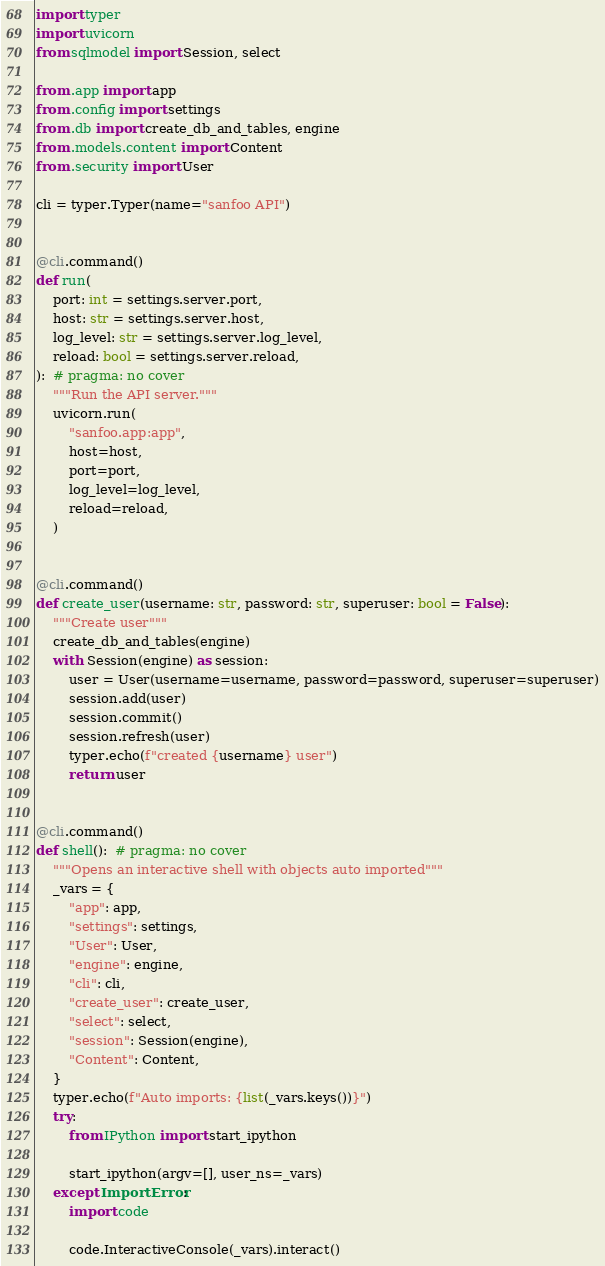<code> <loc_0><loc_0><loc_500><loc_500><_Python_>import typer
import uvicorn
from sqlmodel import Session, select

from .app import app
from .config import settings
from .db import create_db_and_tables, engine
from .models.content import Content
from .security import User

cli = typer.Typer(name="sanfoo API")


@cli.command()
def run(
    port: int = settings.server.port,
    host: str = settings.server.host,
    log_level: str = settings.server.log_level,
    reload: bool = settings.server.reload,
):  # pragma: no cover
    """Run the API server."""
    uvicorn.run(
        "sanfoo.app:app",
        host=host,
        port=port,
        log_level=log_level,
        reload=reload,
    )


@cli.command()
def create_user(username: str, password: str, superuser: bool = False):
    """Create user"""
    create_db_and_tables(engine)
    with Session(engine) as session:
        user = User(username=username, password=password, superuser=superuser)
        session.add(user)
        session.commit()
        session.refresh(user)
        typer.echo(f"created {username} user")
        return user


@cli.command()
def shell():  # pragma: no cover
    """Opens an interactive shell with objects auto imported"""
    _vars = {
        "app": app,
        "settings": settings,
        "User": User,
        "engine": engine,
        "cli": cli,
        "create_user": create_user,
        "select": select,
        "session": Session(engine),
        "Content": Content,
    }
    typer.echo(f"Auto imports: {list(_vars.keys())}")
    try:
        from IPython import start_ipython

        start_ipython(argv=[], user_ns=_vars)
    except ImportError:
        import code

        code.InteractiveConsole(_vars).interact()
</code> 